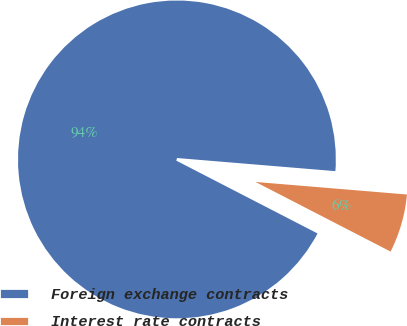<chart> <loc_0><loc_0><loc_500><loc_500><pie_chart><fcel>Foreign exchange contracts<fcel>Interest rate contracts<nl><fcel>93.74%<fcel>6.26%<nl></chart> 